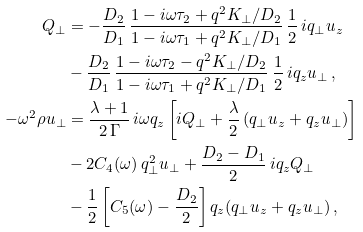<formula> <loc_0><loc_0><loc_500><loc_500>Q _ { \perp } & = - \frac { D _ { 2 } } { D _ { 1 } } \, \frac { 1 - i \omega \tau _ { 2 } + q ^ { 2 } K _ { \perp } / D _ { 2 } } { 1 - i \omega \tau _ { 1 } + q ^ { 2 } K _ { \perp } / D _ { 1 } } \, \frac { 1 } { 2 } \, i q _ { \perp } u _ { z } \\ & - \frac { D _ { 2 } } { D _ { 1 } } \, \frac { 1 - i \omega \tau _ { 2 } - q ^ { 2 } K _ { \perp } / D _ { 2 } } { 1 - i \omega \tau _ { 1 } + q ^ { 2 } K _ { \perp } / D _ { 1 } } \, \frac { 1 } { 2 } \, i q _ { z } u _ { \perp } \, , \\ - \omega ^ { 2 } \rho u _ { \perp } & = \frac { \lambda + 1 } { 2 \, \Gamma } \, i \omega q _ { z } \left [ i Q _ { \perp } + \frac { \lambda } { 2 } \, ( q _ { \perp } u _ { z } + q _ { z } u _ { \perp } ) \right ] \\ & - 2 C _ { 4 } ( \omega ) \, q _ { \perp } ^ { 2 } u _ { \perp } + \frac { D _ { 2 } - D _ { 1 } } { 2 } \, i q _ { z } Q _ { \perp } \\ & - \frac { 1 } { 2 } \left [ C _ { 5 } ( \omega ) - \frac { D _ { 2 } } { 2 } \right ] q _ { z } ( q _ { \perp } u _ { z } + q _ { z } u _ { \perp } ) \, ,</formula> 